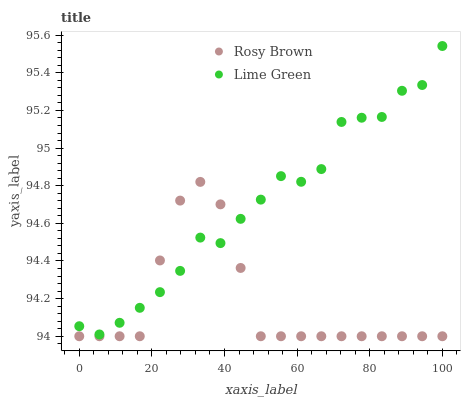Does Rosy Brown have the minimum area under the curve?
Answer yes or no. Yes. Does Lime Green have the maximum area under the curve?
Answer yes or no. Yes. Does Lime Green have the minimum area under the curve?
Answer yes or no. No. Is Rosy Brown the smoothest?
Answer yes or no. Yes. Is Lime Green the roughest?
Answer yes or no. Yes. Is Lime Green the smoothest?
Answer yes or no. No. Does Rosy Brown have the lowest value?
Answer yes or no. Yes. Does Lime Green have the lowest value?
Answer yes or no. No. Does Lime Green have the highest value?
Answer yes or no. Yes. Does Rosy Brown intersect Lime Green?
Answer yes or no. Yes. Is Rosy Brown less than Lime Green?
Answer yes or no. No. Is Rosy Brown greater than Lime Green?
Answer yes or no. No. 